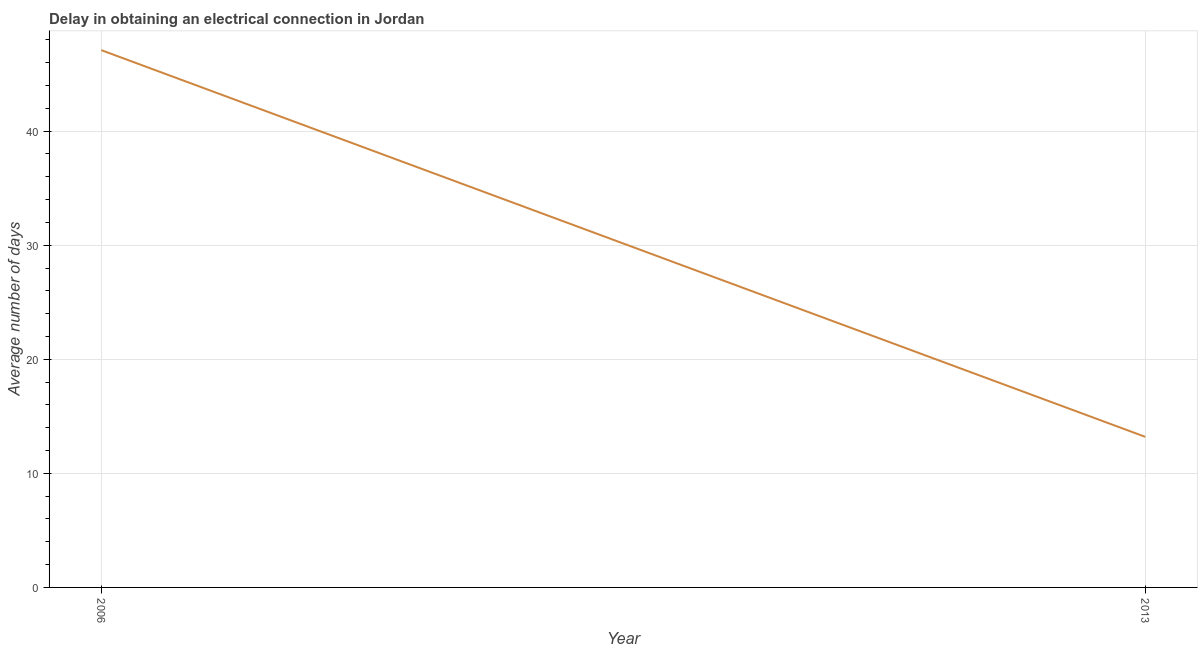Across all years, what is the maximum dalay in electrical connection?
Provide a short and direct response. 47.1. Across all years, what is the minimum dalay in electrical connection?
Provide a succinct answer. 13.2. In which year was the dalay in electrical connection maximum?
Keep it short and to the point. 2006. What is the sum of the dalay in electrical connection?
Your answer should be compact. 60.3. What is the difference between the dalay in electrical connection in 2006 and 2013?
Provide a short and direct response. 33.9. What is the average dalay in electrical connection per year?
Your response must be concise. 30.15. What is the median dalay in electrical connection?
Provide a succinct answer. 30.15. Do a majority of the years between 2013 and 2006 (inclusive) have dalay in electrical connection greater than 24 days?
Your answer should be very brief. No. What is the ratio of the dalay in electrical connection in 2006 to that in 2013?
Give a very brief answer. 3.57. Is the dalay in electrical connection in 2006 less than that in 2013?
Your response must be concise. No. In how many years, is the dalay in electrical connection greater than the average dalay in electrical connection taken over all years?
Your response must be concise. 1. What is the difference between two consecutive major ticks on the Y-axis?
Ensure brevity in your answer.  10. Does the graph contain grids?
Keep it short and to the point. Yes. What is the title of the graph?
Your answer should be compact. Delay in obtaining an electrical connection in Jordan. What is the label or title of the Y-axis?
Give a very brief answer. Average number of days. What is the Average number of days in 2006?
Make the answer very short. 47.1. What is the difference between the Average number of days in 2006 and 2013?
Offer a terse response. 33.9. What is the ratio of the Average number of days in 2006 to that in 2013?
Keep it short and to the point. 3.57. 